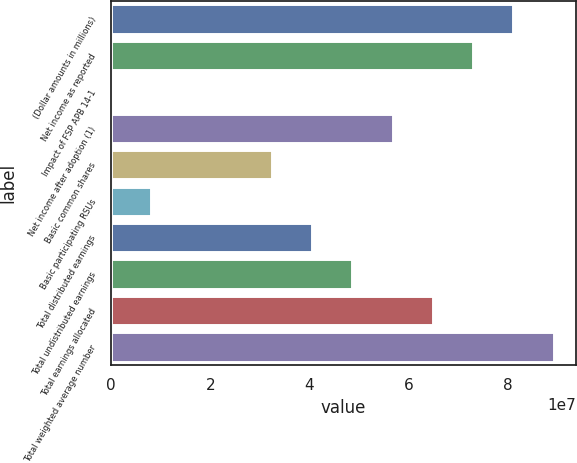Convert chart. <chart><loc_0><loc_0><loc_500><loc_500><bar_chart><fcel>(Dollar amounts in millions)<fcel>Net income as reported<fcel>Impact of FSP APB 14-1<fcel>Net income after adoption (1)<fcel>Basic common shares<fcel>Basic participating RSUs<fcel>Total distributed earnings<fcel>Total undistributed earnings<fcel>Total earnings allocated<fcel>Total weighted average number<nl><fcel>8.11639e+07<fcel>7.30475e+07<fcel>1<fcel>5.68147e+07<fcel>3.24656e+07<fcel>8.11639e+06<fcel>4.05819e+07<fcel>4.86983e+07<fcel>6.49311e+07<fcel>8.92803e+07<nl></chart> 